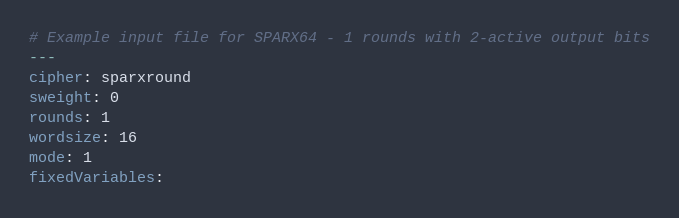<code> <loc_0><loc_0><loc_500><loc_500><_YAML_># Example input file for SPARX64 - 1 rounds with 2-active output bits
---
cipher: sparxround
sweight: 0
rounds: 1
wordsize: 16
mode: 1
fixedVariables:</code> 